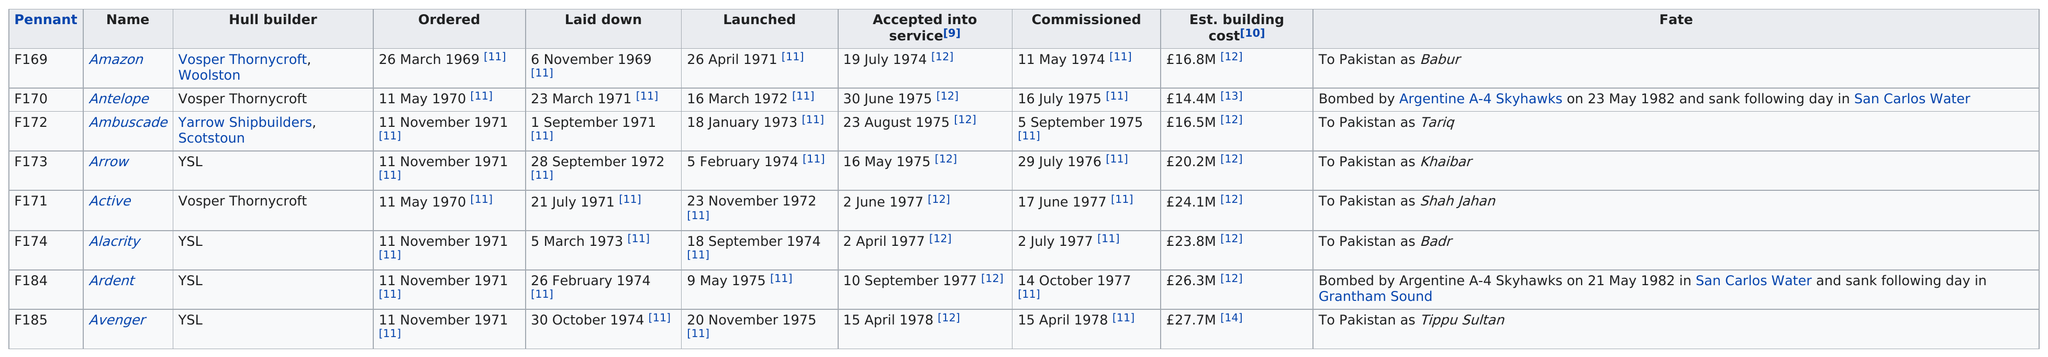Mention a couple of crucial points in this snapshot. I want to know the number of ships that went to Pakistan. Specifically, I'm asking about the number of ships that went to Pakistan, period. The Arrow was ordered on November 11, 1971, and its previous ship was the Ambuscade. After Ardent, a total of one ship was built. The Avenger ship had the highest estimated cost to build among all ships. According to the chart, November had the most ships ordered. 